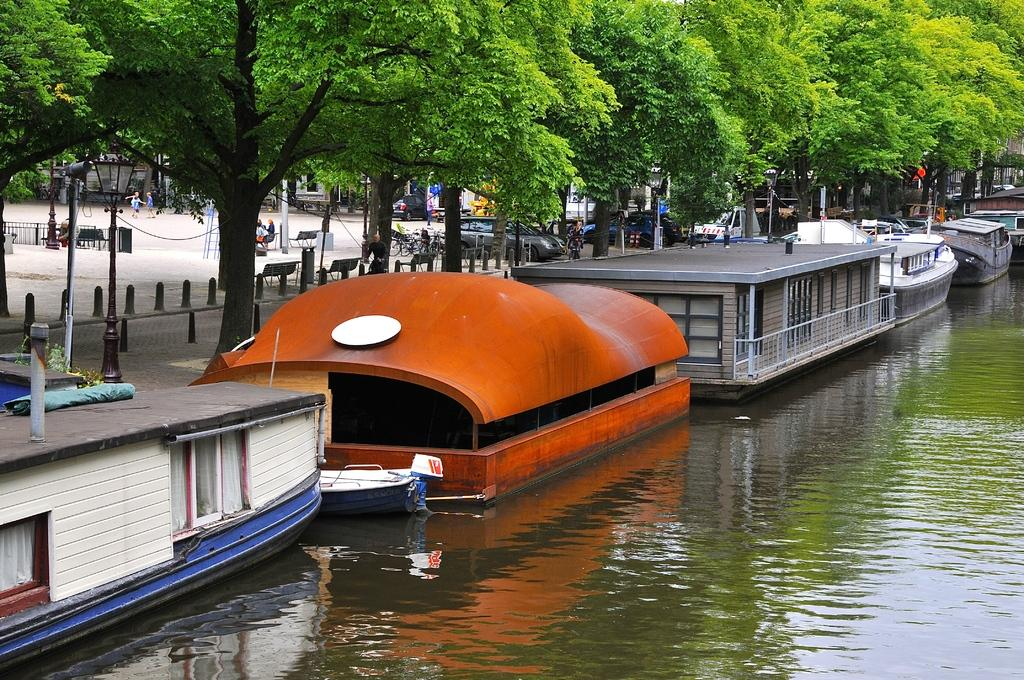What is in the front of the image? There is water in the front of the image. What is on the water? There are boats on the water. What can be seen in the background of the image? There are trees, vehicles, buildings, and people in the background of the image. What type of office can be seen in the image? There is no office present in the image. How does the wind affect the people in the image? There is no mention of wind in the image, so its effect on the people cannot be determined. 